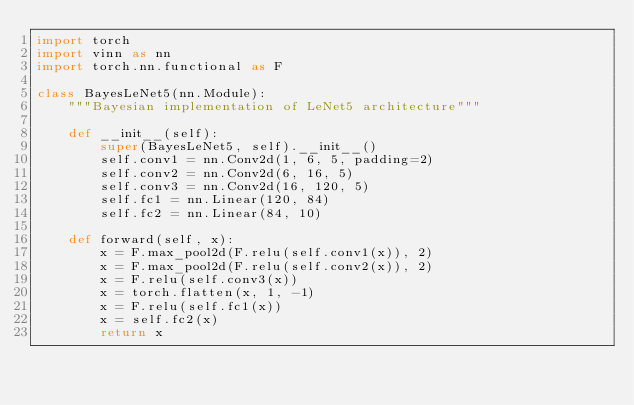Convert code to text. <code><loc_0><loc_0><loc_500><loc_500><_Python_>import torch
import vinn as nn
import torch.nn.functional as F

class BayesLeNet5(nn.Module):
    """Bayesian implementation of LeNet5 architecture"""

    def __init__(self):
        super(BayesLeNet5, self).__init__()
        self.conv1 = nn.Conv2d(1, 6, 5, padding=2)
        self.conv2 = nn.Conv2d(6, 16, 5)
        self.conv3 = nn.Conv2d(16, 120, 5)
        self.fc1 = nn.Linear(120, 84)
        self.fc2 = nn.Linear(84, 10)
        
    def forward(self, x):
        x = F.max_pool2d(F.relu(self.conv1(x)), 2)
        x = F.max_pool2d(F.relu(self.conv2(x)), 2)
        x = F.relu(self.conv3(x))
        x = torch.flatten(x, 1, -1)
        x = F.relu(self.fc1(x))
        x = self.fc2(x)
        return x</code> 